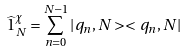<formula> <loc_0><loc_0><loc_500><loc_500>\widehat { 1 } _ { N } ^ { \chi } = \sum _ { n = 0 } ^ { N - 1 } | { q } _ { n } , N > < { q } _ { n } , N |</formula> 